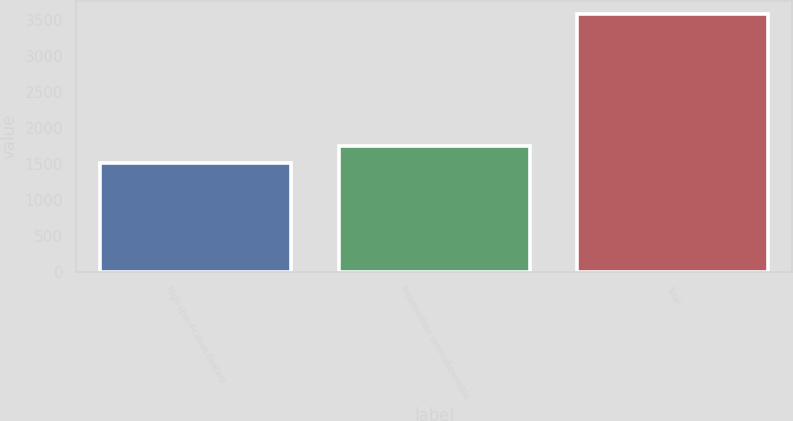Convert chart to OTSL. <chart><loc_0><loc_0><loc_500><loc_500><bar_chart><fcel>High specification floaters<fcel>Intermediate semisubmersible<fcel>Total<nl><fcel>1507<fcel>1747<fcel>3583<nl></chart> 